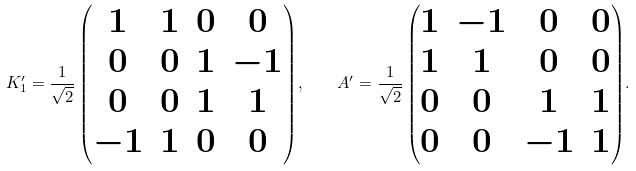Convert formula to latex. <formula><loc_0><loc_0><loc_500><loc_500>K _ { 1 } ^ { \prime } = { \frac { 1 } { \sqrt { 2 } } \begin{pmatrix} 1 & 1 & 0 & 0 \\ 0 & 0 & 1 & - 1 \\ 0 & 0 & 1 & 1 \\ - 1 & 1 & 0 & 0 \\ \end{pmatrix} } , \quad A ^ { \prime } = { \frac { 1 } { \sqrt { 2 } } \begin{pmatrix} 1 & - 1 & 0 & 0 \\ 1 & 1 & 0 & 0 \\ 0 & 0 & 1 & 1 \\ 0 & 0 & - 1 & 1 \\ \end{pmatrix} } .</formula> 